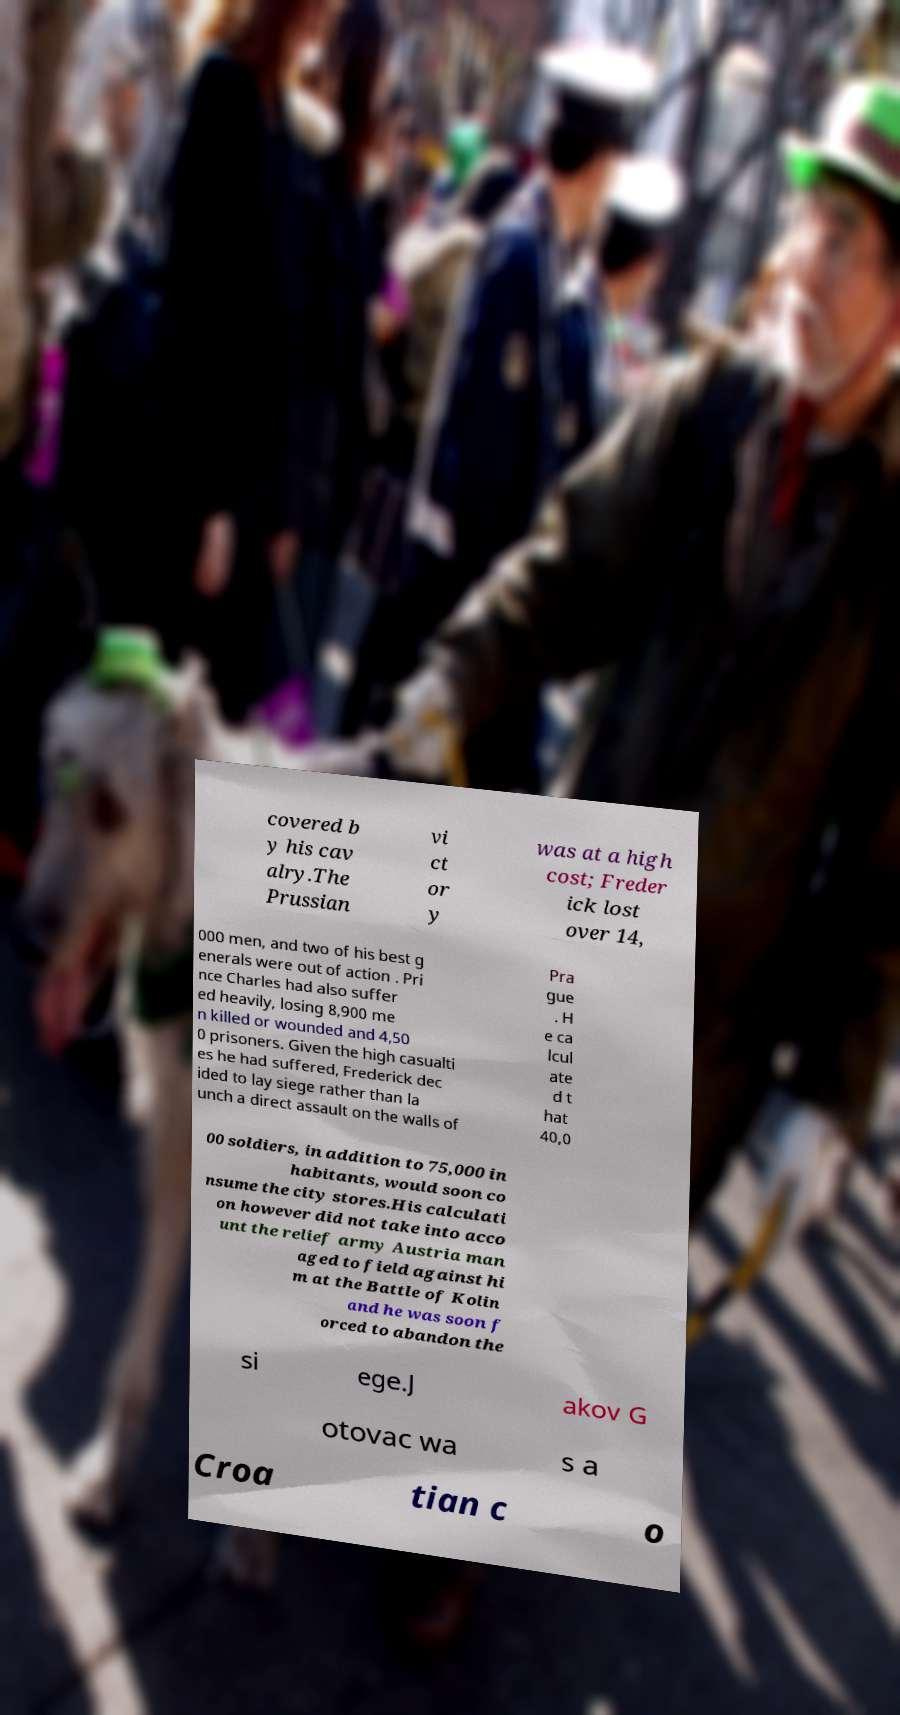Please identify and transcribe the text found in this image. covered b y his cav alry.The Prussian vi ct or y was at a high cost; Freder ick lost over 14, 000 men, and two of his best g enerals were out of action . Pri nce Charles had also suffer ed heavily, losing 8,900 me n killed or wounded and 4,50 0 prisoners. Given the high casualti es he had suffered, Frederick dec ided to lay siege rather than la unch a direct assault on the walls of Pra gue . H e ca lcul ate d t hat 40,0 00 soldiers, in addition to 75,000 in habitants, would soon co nsume the city stores.His calculati on however did not take into acco unt the relief army Austria man aged to field against hi m at the Battle of Kolin and he was soon f orced to abandon the si ege.J akov G otovac wa s a Croa tian c o 